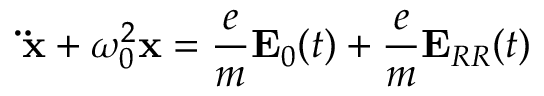Convert formula to latex. <formula><loc_0><loc_0><loc_500><loc_500>\ddot { x } + \omega _ { 0 } ^ { 2 } x = { \frac { e } { m } } E _ { 0 } ( t ) + { \frac { e } { m } } E _ { R R } ( t )</formula> 